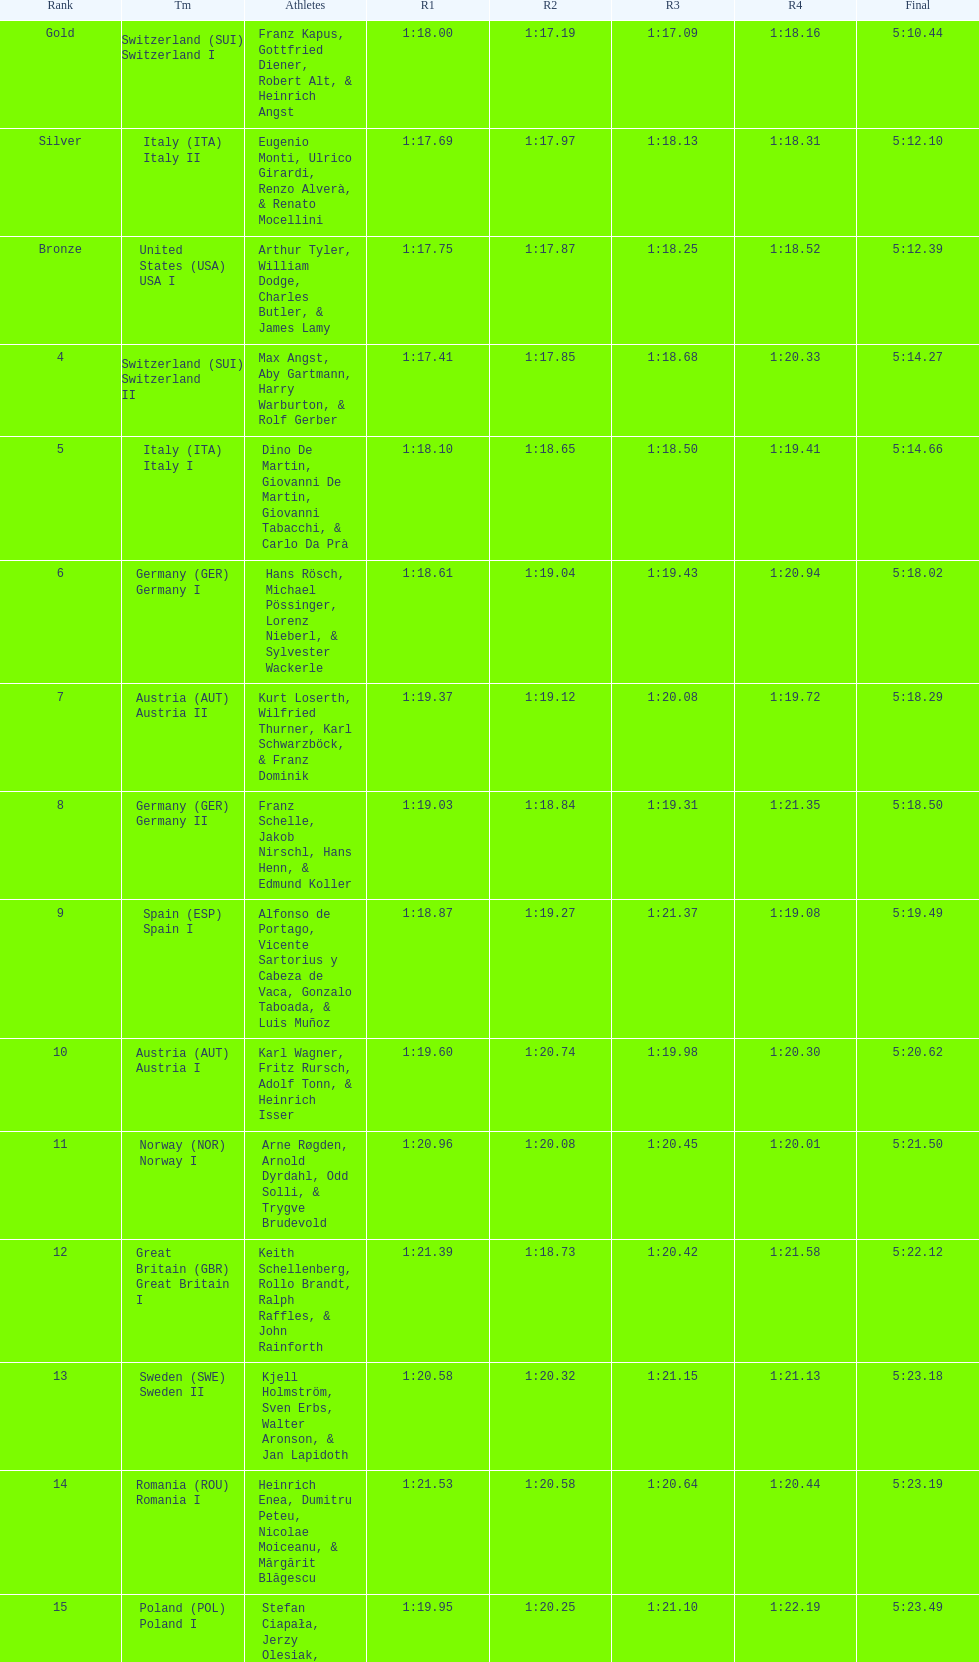Who is the previous team to italy (ita) italy ii? Switzerland (SUI) Switzerland I. 